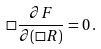Convert formula to latex. <formula><loc_0><loc_0><loc_500><loc_500>\Box \frac { \partial { F } } { \partial ( \Box R ) } = 0 \, { . }</formula> 